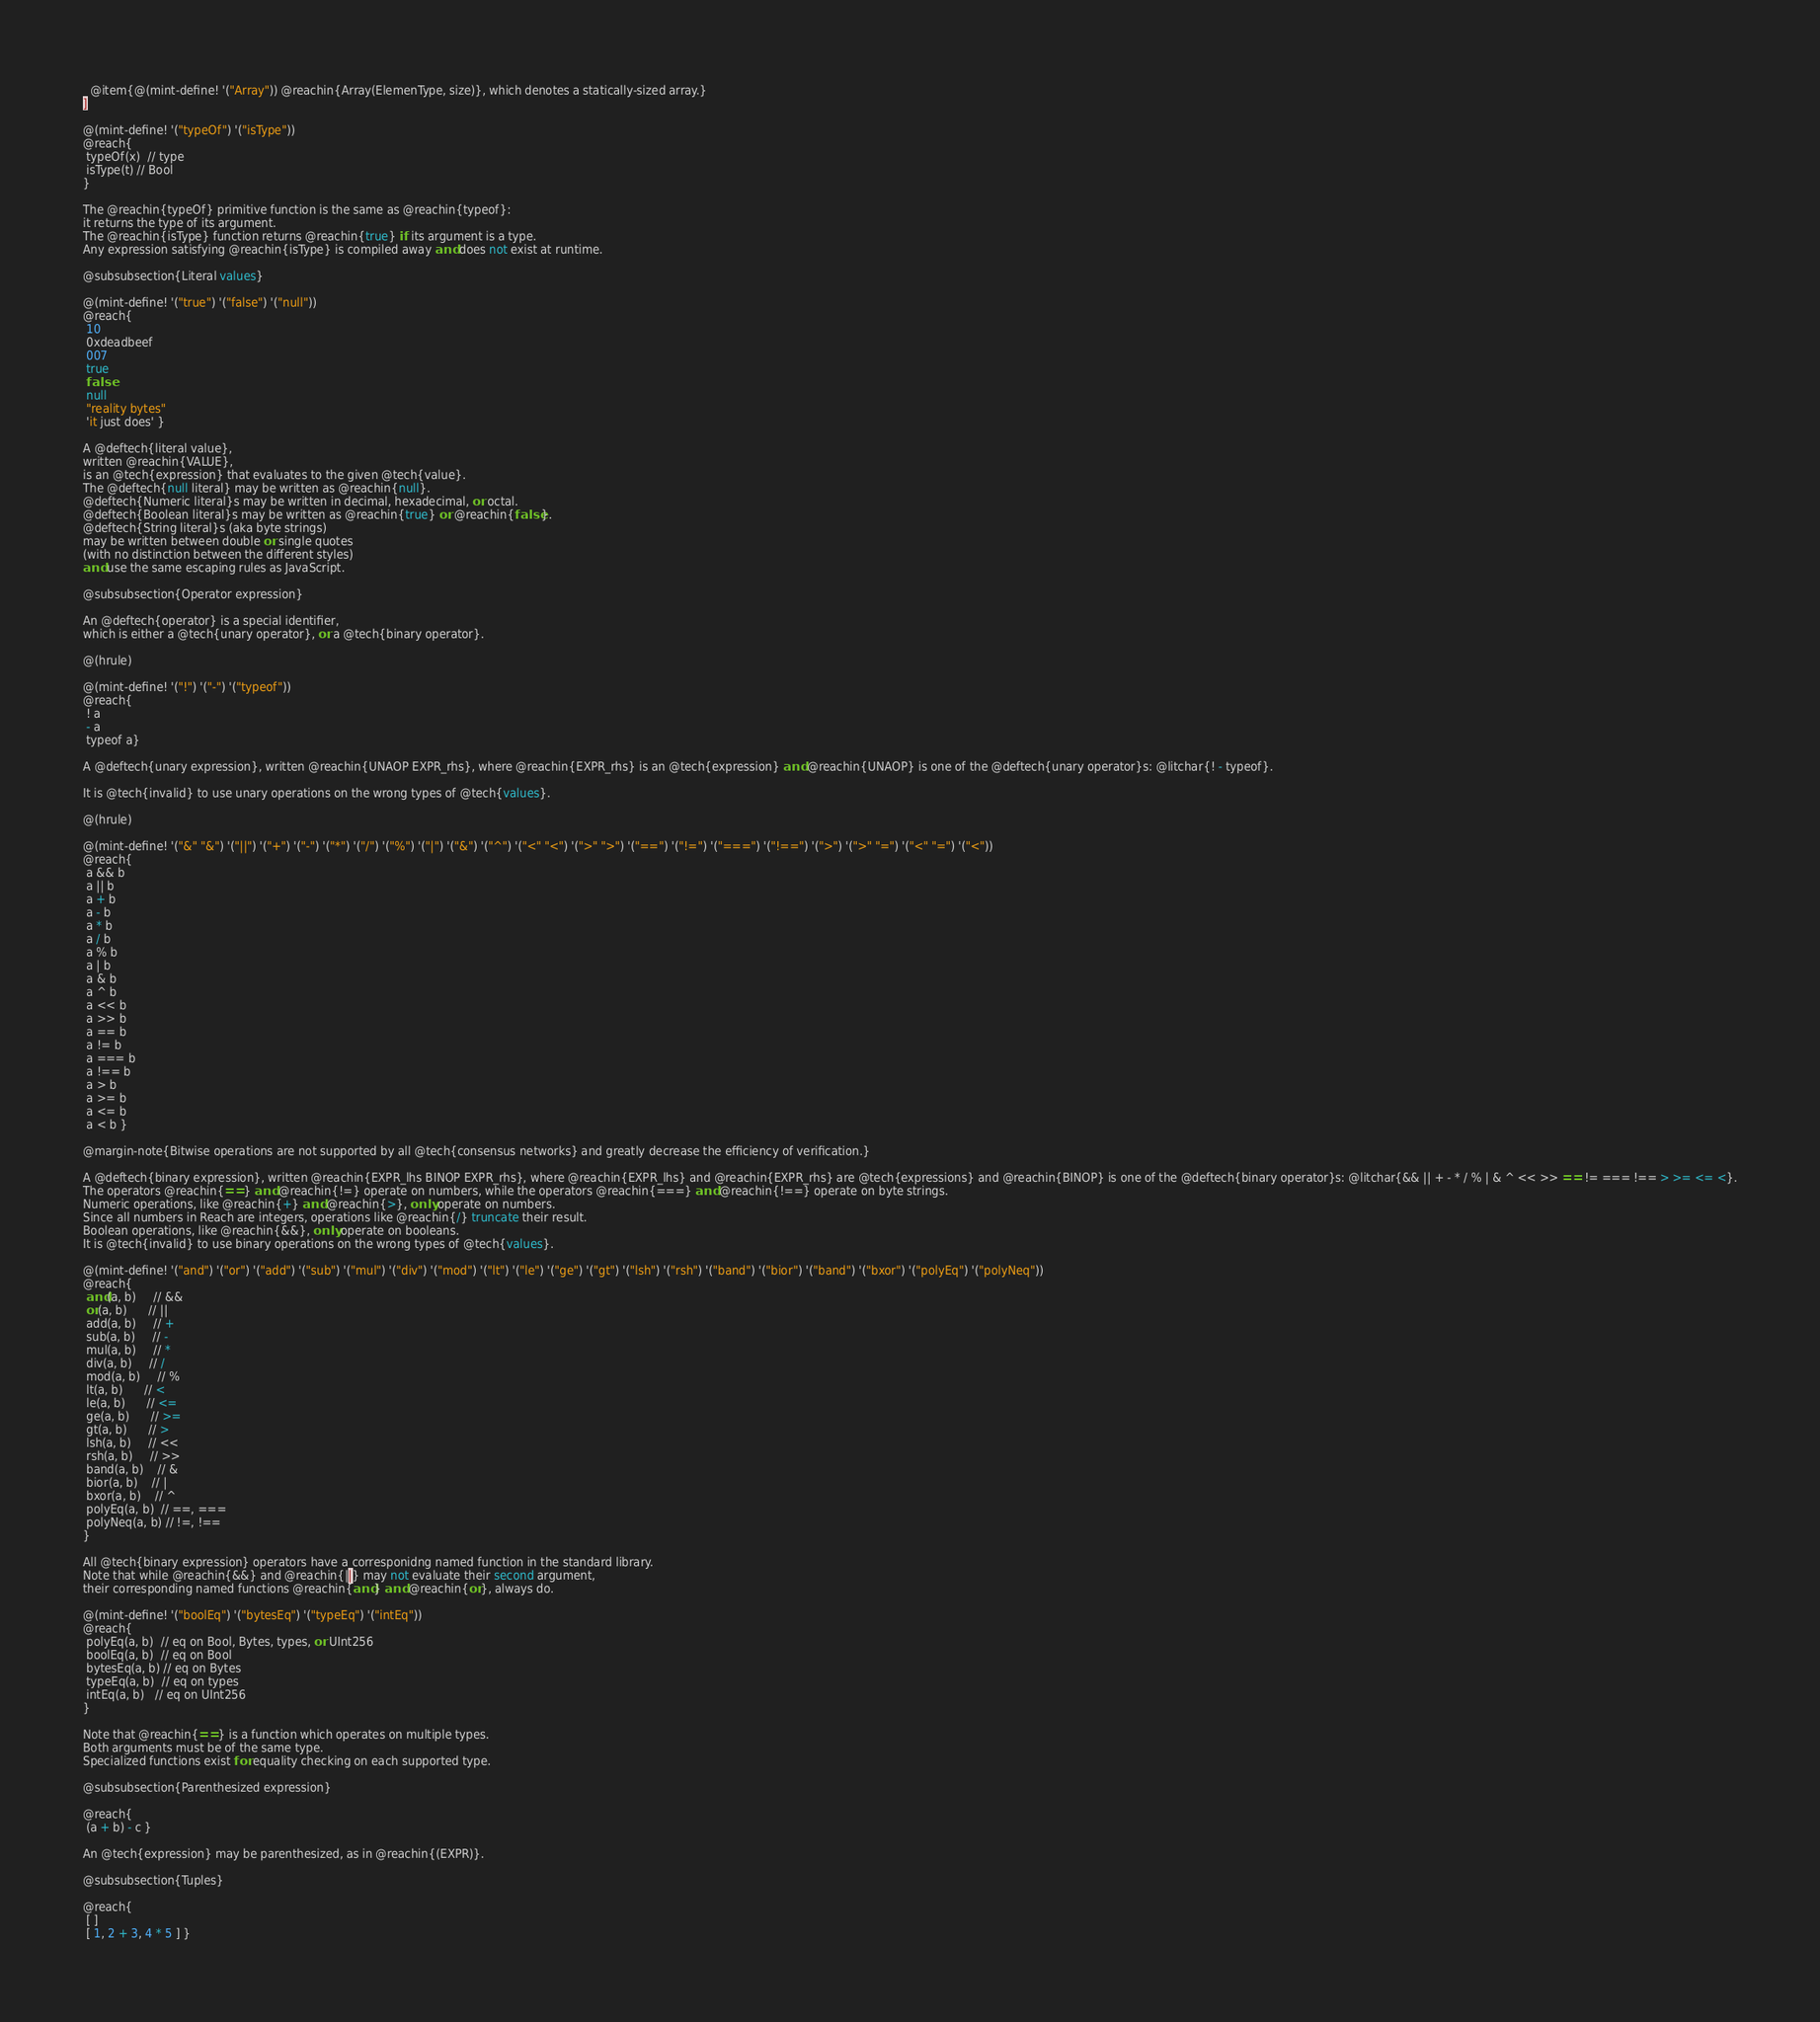Convert code to text. <code><loc_0><loc_0><loc_500><loc_500><_Racket_>  @item{@(mint-define! '("Array")) @reachin{Array(ElemenType, size)}, which denotes a statically-sized array.}
]

@(mint-define! '("typeOf") '("isType"))
@reach{
 typeOf(x)  // type
 isType(t) // Bool
}

The @reachin{typeOf} primitive function is the same as @reachin{typeof}:
it returns the type of its argument.
The @reachin{isType} function returns @reachin{true} if its argument is a type.
Any expression satisfying @reachin{isType} is compiled away and does not exist at runtime.

@subsubsection{Literal values}

@(mint-define! '("true") '("false") '("null"))
@reach{
 10
 0xdeadbeef
 007
 true
 false
 null
 "reality bytes"
 'it just does' }

A @deftech{literal value},
written @reachin{VALUE},
is an @tech{expression} that evaluates to the given @tech{value}.
The @deftech{null literal} may be written as @reachin{null}.
@deftech{Numeric literal}s may be written in decimal, hexadecimal, or octal.
@deftech{Boolean literal}s may be written as @reachin{true} or @reachin{false}.
@deftech{String literal}s (aka byte strings)
may be written between double or single quotes
(with no distinction between the different styles)
and use the same escaping rules as JavaScript.

@subsubsection{Operator expression}

An @deftech{operator} is a special identifier,
which is either a @tech{unary operator}, or a @tech{binary operator}.

@(hrule)

@(mint-define! '("!") '("-") '("typeof"))
@reach{
 ! a
 - a
 typeof a}

A @deftech{unary expression}, written @reachin{UNAOP EXPR_rhs}, where @reachin{EXPR_rhs} is an @tech{expression} and @reachin{UNAOP} is one of the @deftech{unary operator}s: @litchar{! - typeof}.

It is @tech{invalid} to use unary operations on the wrong types of @tech{values}.

@(hrule)

@(mint-define! '("&" "&") '("||") '("+") '("-") '("*") '("/") '("%") '("|") '("&") '("^") '("<" "<") '(">" ">") '("==") '("!=") '("===") '("!==") '(">") '(">" "=") '("<" "=") '("<"))
@reach{
 a && b
 a || b
 a + b
 a - b
 a * b
 a / b
 a % b
 a | b
 a & b
 a ^ b
 a << b
 a >> b
 a == b
 a != b
 a === b
 a !== b
 a > b
 a >= b
 a <= b
 a < b }

@margin-note{Bitwise operations are not supported by all @tech{consensus networks} and greatly decrease the efficiency of verification.}

A @deftech{binary expression}, written @reachin{EXPR_lhs BINOP EXPR_rhs}, where @reachin{EXPR_lhs} and @reachin{EXPR_rhs} are @tech{expressions} and @reachin{BINOP} is one of the @deftech{binary operator}s: @litchar{&& || + - * / % | & ^ << >> == != === !== > >= <= <}.
The operators @reachin{==} and @reachin{!=} operate on numbers, while the operators @reachin{===} and @reachin{!==} operate on byte strings.
Numeric operations, like @reachin{+} and @reachin{>}, only operate on numbers.
Since all numbers in Reach are integers, operations like @reachin{/} truncate their result.
Boolean operations, like @reachin{&&}, only operate on booleans.
It is @tech{invalid} to use binary operations on the wrong types of @tech{values}.

@(mint-define! '("and") '("or") '("add") '("sub") '("mul") '("div") '("mod") '("lt") '("le") '("ge") '("gt") '("lsh") '("rsh") '("band") '("bior") '("band") '("bxor") '("polyEq") '("polyNeq"))
@reach{
 and(a, b)     // &&
 or(a, b)      // ||
 add(a, b)     // +
 sub(a, b)     // -
 mul(a, b)     // *
 div(a, b)     // /
 mod(a, b)     // %
 lt(a, b)      // <
 le(a, b)      // <=
 ge(a, b)      // >=
 gt(a, b)      // >
 lsh(a, b)     // <<
 rsh(a, b)     // >>
 band(a, b)    // &
 bior(a, b)    // |
 bxor(a, b)    // ^
 polyEq(a, b)  // ==, ===
 polyNeq(a, b) // !=, !==
}

All @tech{binary expression} operators have a corresponidng named function in the standard library.
Note that while @reachin{&&} and @reachin{||} may not evaluate their second argument,
their corresponding named functions @reachin{and} and @reachin{or}, always do.

@(mint-define! '("boolEq") '("bytesEq") '("typeEq") '("intEq"))
@reach{
 polyEq(a, b)  // eq on Bool, Bytes, types, or UInt256
 boolEq(a, b)  // eq on Bool
 bytesEq(a, b) // eq on Bytes
 typeEq(a, b)  // eq on types
 intEq(a, b)   // eq on UInt256
}

Note that @reachin{==} is a function which operates on multiple types.
Both arguments must be of the same type.
Specialized functions exist for equality checking on each supported type.

@subsubsection{Parenthesized expression}

@reach{
 (a + b) - c }

An @tech{expression} may be parenthesized, as in @reachin{(EXPR)}.

@subsubsection{Tuples}

@reach{
 [ ]
 [ 1, 2 + 3, 4 * 5 ] }
</code> 